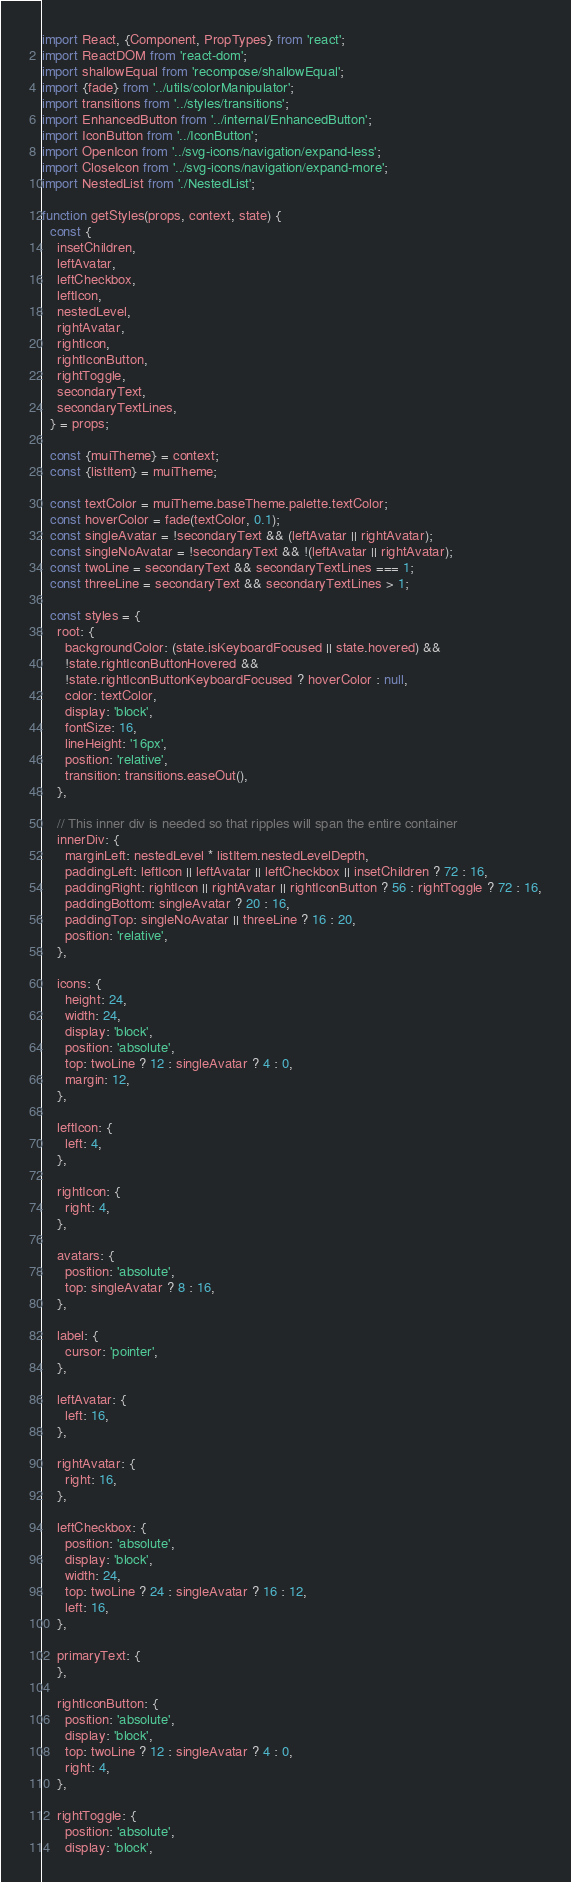Convert code to text. <code><loc_0><loc_0><loc_500><loc_500><_JavaScript_>import React, {Component, PropTypes} from 'react';
import ReactDOM from 'react-dom';
import shallowEqual from 'recompose/shallowEqual';
import {fade} from '../utils/colorManipulator';
import transitions from '../styles/transitions';
import EnhancedButton from '../internal/EnhancedButton';
import IconButton from '../IconButton';
import OpenIcon from '../svg-icons/navigation/expand-less';
import CloseIcon from '../svg-icons/navigation/expand-more';
import NestedList from './NestedList';

function getStyles(props, context, state) {
  const {
    insetChildren,
    leftAvatar,
    leftCheckbox,
    leftIcon,
    nestedLevel,
    rightAvatar,
    rightIcon,
    rightIconButton,
    rightToggle,
    secondaryText,
    secondaryTextLines,
  } = props;

  const {muiTheme} = context;
  const {listItem} = muiTheme;

  const textColor = muiTheme.baseTheme.palette.textColor;
  const hoverColor = fade(textColor, 0.1);
  const singleAvatar = !secondaryText && (leftAvatar || rightAvatar);
  const singleNoAvatar = !secondaryText && !(leftAvatar || rightAvatar);
  const twoLine = secondaryText && secondaryTextLines === 1;
  const threeLine = secondaryText && secondaryTextLines > 1;

  const styles = {
    root: {
      backgroundColor: (state.isKeyboardFocused || state.hovered) &&
      !state.rightIconButtonHovered &&
      !state.rightIconButtonKeyboardFocused ? hoverColor : null,
      color: textColor,
      display: 'block',
      fontSize: 16,
      lineHeight: '16px',
      position: 'relative',
      transition: transitions.easeOut(),
    },

    // This inner div is needed so that ripples will span the entire container
    innerDiv: {
      marginLeft: nestedLevel * listItem.nestedLevelDepth,
      paddingLeft: leftIcon || leftAvatar || leftCheckbox || insetChildren ? 72 : 16,
      paddingRight: rightIcon || rightAvatar || rightIconButton ? 56 : rightToggle ? 72 : 16,
      paddingBottom: singleAvatar ? 20 : 16,
      paddingTop: singleNoAvatar || threeLine ? 16 : 20,
      position: 'relative',
    },

    icons: {
      height: 24,
      width: 24,
      display: 'block',
      position: 'absolute',
      top: twoLine ? 12 : singleAvatar ? 4 : 0,
      margin: 12,
    },

    leftIcon: {
      left: 4,
    },

    rightIcon: {
      right: 4,
    },

    avatars: {
      position: 'absolute',
      top: singleAvatar ? 8 : 16,
    },

    label: {
      cursor: 'pointer',
    },

    leftAvatar: {
      left: 16,
    },

    rightAvatar: {
      right: 16,
    },

    leftCheckbox: {
      position: 'absolute',
      display: 'block',
      width: 24,
      top: twoLine ? 24 : singleAvatar ? 16 : 12,
      left: 16,
    },

    primaryText: {
    },

    rightIconButton: {
      position: 'absolute',
      display: 'block',
      top: twoLine ? 12 : singleAvatar ? 4 : 0,
      right: 4,
    },

    rightToggle: {
      position: 'absolute',
      display: 'block',</code> 